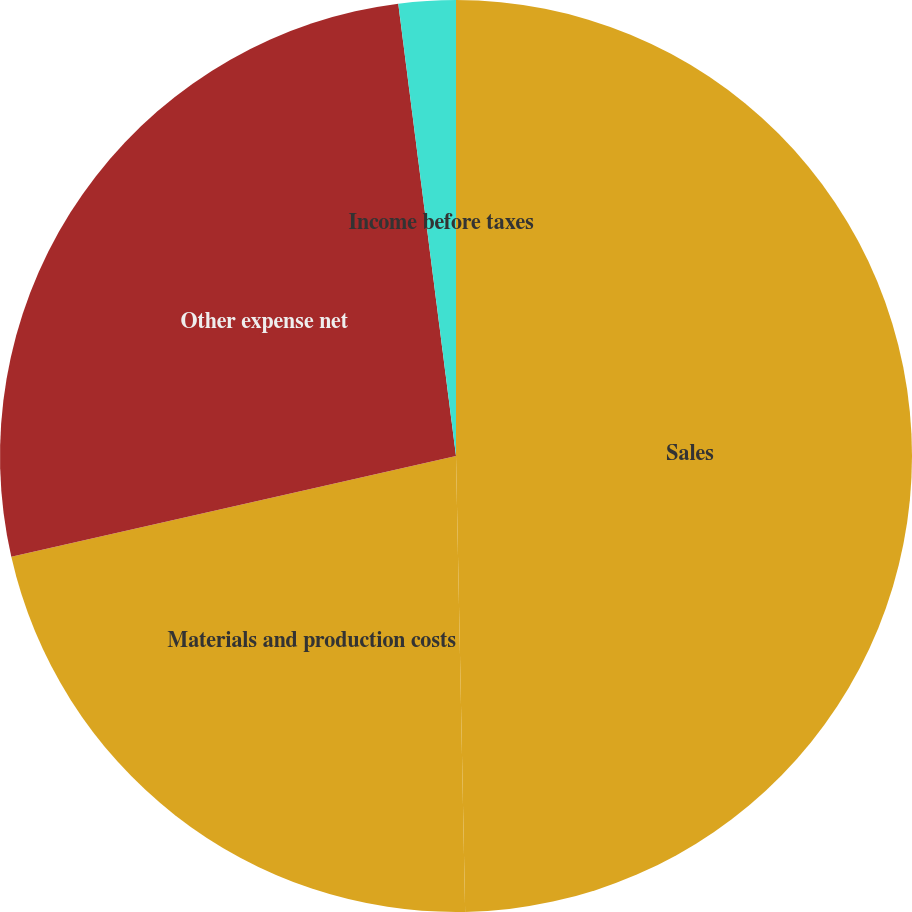Convert chart to OTSL. <chart><loc_0><loc_0><loc_500><loc_500><pie_chart><fcel>Sales<fcel>Materials and production costs<fcel>Other expense net<fcel>Income before taxes<nl><fcel>49.68%<fcel>21.77%<fcel>26.53%<fcel>2.02%<nl></chart> 